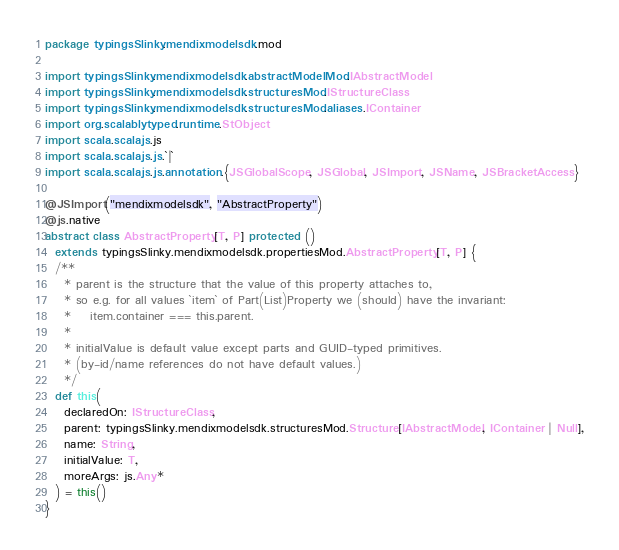Convert code to text. <code><loc_0><loc_0><loc_500><loc_500><_Scala_>package typingsSlinky.mendixmodelsdk.mod

import typingsSlinky.mendixmodelsdk.abstractModelMod.IAbstractModel
import typingsSlinky.mendixmodelsdk.structuresMod.IStructureClass
import typingsSlinky.mendixmodelsdk.structuresMod.aliases.IContainer
import org.scalablytyped.runtime.StObject
import scala.scalajs.js
import scala.scalajs.js.`|`
import scala.scalajs.js.annotation.{JSGlobalScope, JSGlobal, JSImport, JSName, JSBracketAccess}

@JSImport("mendixmodelsdk", "AbstractProperty")
@js.native
abstract class AbstractProperty[T, P] protected ()
  extends typingsSlinky.mendixmodelsdk.propertiesMod.AbstractProperty[T, P] {
  /**
    * parent is the structure that the value of this property attaches to,
    * so e.g. for all values `item` of Part(List)Property we (should) have the invariant:
    *    item.container === this.parent.
    *
    * initialValue is default value except parts and GUID-typed primitives.
    * (by-id/name references do not have default values.)
    */
  def this(
    declaredOn: IStructureClass,
    parent: typingsSlinky.mendixmodelsdk.structuresMod.Structure[IAbstractModel, IContainer | Null],
    name: String,
    initialValue: T,
    moreArgs: js.Any*
  ) = this()
}
</code> 